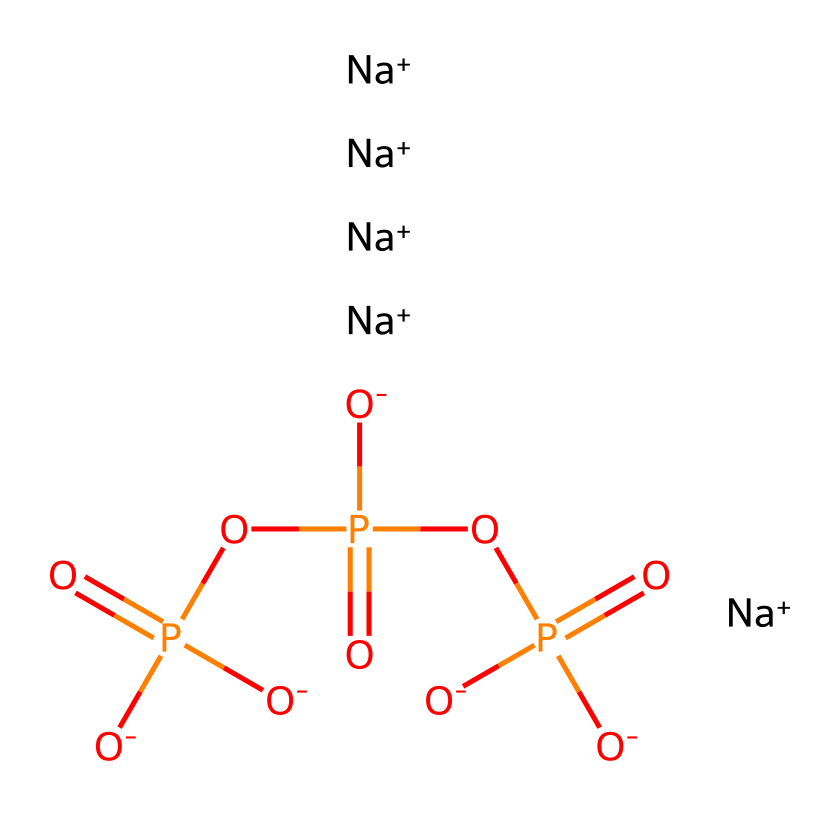What is the molecular formula of this compound? To determine the molecular formula, we count the number of each type of atom present based on the SMILES representation. The representation includes five sodium atoms, one phosphorus atom, and a total of four oxygen atoms (from the phosphate groups). Thus, the molecular formula is Na5O4P.
Answer: Na5O4P How many phosphorus atoms are in the structure? By analyzing the chemical structure, we notice that it contains exactly one phosphorus atom, which is directly represented in the SMILES as the central atom linked to four oxygen groups.
Answer: 1 What is the charge of sodium in this compound? In the SMILES notation, sodium is indicated with a "+" which means that each sodium ion has a +1 charge. Since there are five sodium ions, the overall positive charge contributed by sodium in this compound is +5.
Answer: +1 How many phosphate groups are present in sodium tripolyphosphate? The tripolyphosphate structure consists of three phosphate groups, which are identifiable by the phosphate motifs O=P and the associated oxygen atoms. Counted from the SMILES representation, we can identify three distinct phosphate connections leading to this total.
Answer: 3 What type of compound is sodium tripolyphosphate? Sodium tripolyphosphate is classified as a salt due to the presence of sodium ions paired with phosphate anions. The SMILES notation shows the presence of multiple sodium ions which typically indicates it is a salt formed from an acid (phosphoric acid here) and a base (sodium hydroxide).
Answer: salt What role do phosphates play in food preservation? Phosphates, such as those in sodium tripolyphosphate, serve as preservatives in food by binding with water and preventing microbial growth, thereby enhancing moisture retention and overall shelf-life. Their chemical structure and interactions with food components allow them to inhibit spoilage.
Answer: preservatives 